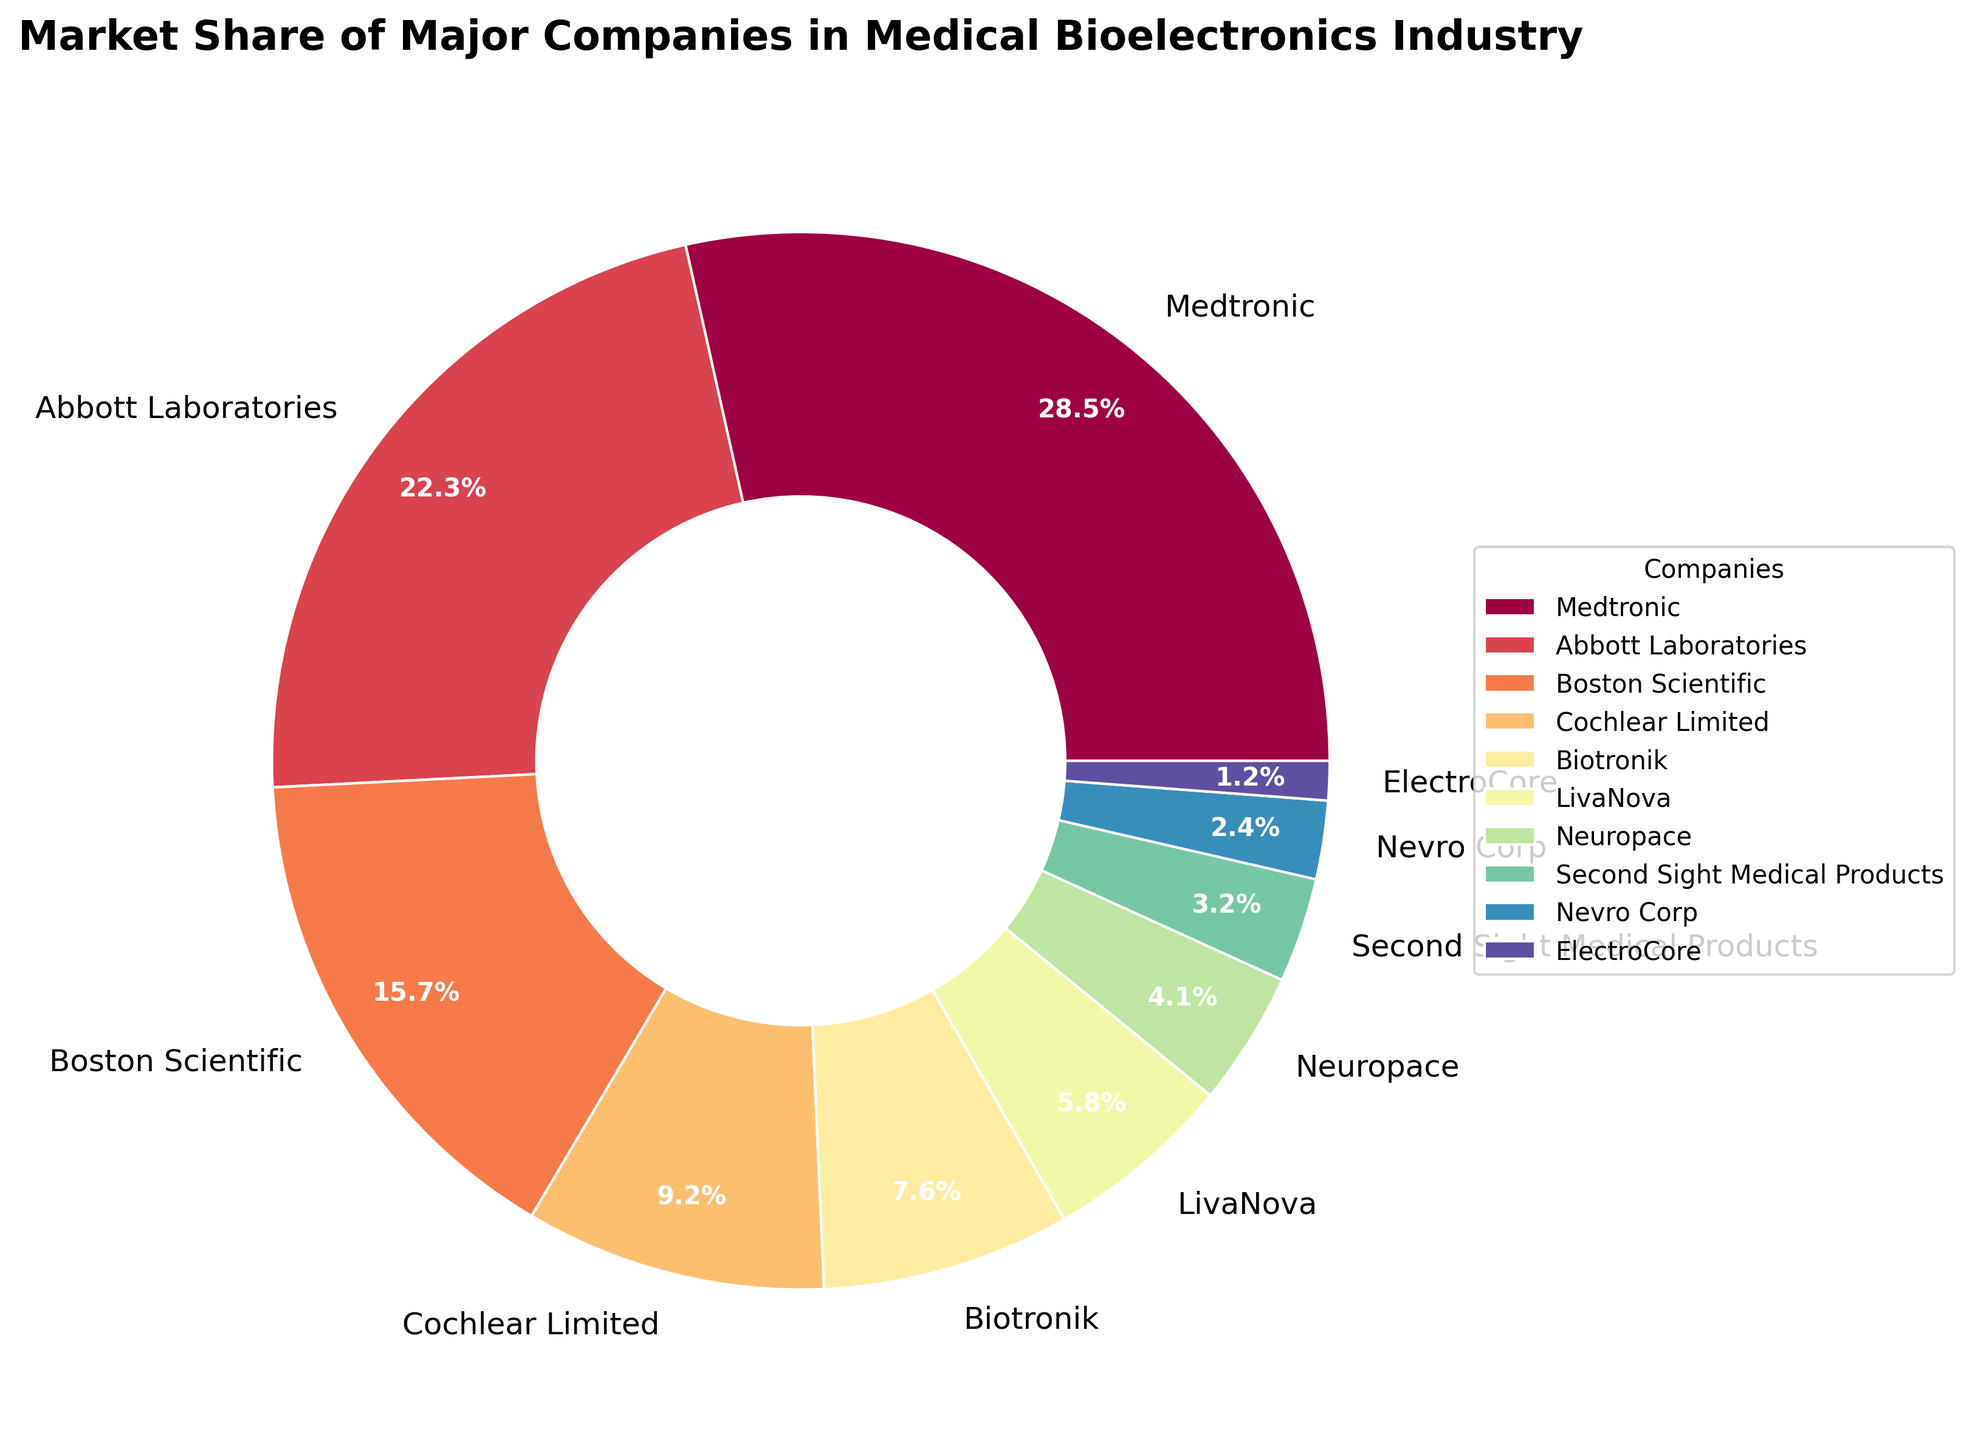What is the market share of Medtronic? Medtronic's market share is directly labeled on the chart. We can see it is 28.5%.
Answer: 28.5% Which company has the lowest market share? By looking at the percentages on the chart, ElectroCore has the smallest slice, representing 1.2% of the market.
Answer: ElectroCore What is the combined market share of Abbott Laboratories and Boston Scientific? Add up the individual market shares of Abbott Laboratories (22.3%) and Boston Scientific (15.7%): 22.3 + 15.7 = 38%.
Answer: 38% Which company has a larger market share: Cochlear Limited or Biotronik? By comparing the slices, Cochlear Limited has a larger share (9.2%) than Biotronik (7.6%).
Answer: Cochlear Limited How much greater is Medtronic's market share compared to Nevro Corp’s market share? Subtract the market share of Nevro Corp (2.4%) from Medtronic's market share (28.5%): 28.5 - 2.4 = 26.1%.
Answer: 26.1% What is the total market share of companies with less than 10% market share? Add the market shares of companies with less than 10%: Cochlear Limited (9.2%), Biotronik (7.6%), LivaNova (5.8%), Neuropace (4.1%), Second Sight Medical Products (3.2%), Nevro Corp (2.4%) and ElectroCore (1.2%): 9.2 + 7.6 + 5.8 + 4.1 + 3.2 + 2.4 + 1.2 = 33.5%.
Answer: 33.5% Which company has a similar market share to LivaNova? By comparing the slices, Neuropace has a market share close to LivaNova’s. LivaNova has 5.8%, and Neuropace has 4.1%.
Answer: Neuropace What is the difference in market share between the largest and the second-largest companies? Medtronic has the largest market share (28.5%), and Abbott Laboratories has the second-largest (22.3%). The difference is 28.5 - 22.3 = 6.2%.
Answer: 6.2% How many companies have a market share greater than 7%? Count the segments with a market share larger than 7%. Medtronic (28.5%), Abbott Laboratories (22.3%), Boston Scientific (15.7%), and Cochlear Limited (9.2%) each have a market share greater than 7%. So, 4 companies.
Answer: 4 companies What color is the section representing Second Sight Medical Products? By observing the visual colors in the pie chart, the section representing Second Sight Medical Products is colored purple.
Answer: Purple 